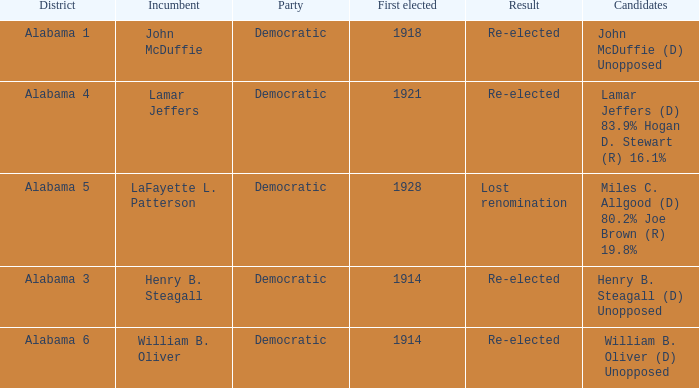How many in lost renomination results were elected first? 1928.0. 